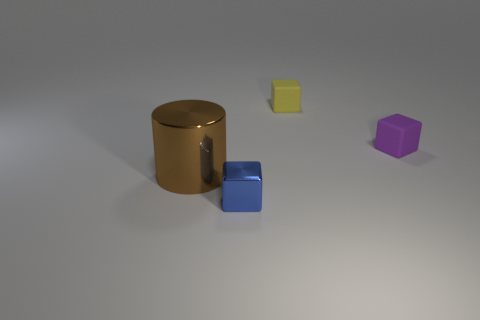Is there any other thing that is the same size as the metal cylinder?
Your response must be concise. No. There is a blue object that is the same shape as the purple matte object; what is its material?
Keep it short and to the point. Metal. How many things are tiny objects to the right of the blue shiny object or cubes to the right of the blue shiny block?
Your answer should be very brief. 2. The small yellow thing that is made of the same material as the purple block is what shape?
Ensure brevity in your answer.  Cube. How many small yellow matte blocks are there?
Make the answer very short. 1. What number of things are either things that are behind the tiny blue object or purple things?
Offer a terse response. 3. What number of other things are the same color as the big object?
Provide a short and direct response. 0. What number of tiny things are rubber cubes or purple rubber objects?
Make the answer very short. 2. Are there more tiny metallic objects than things?
Ensure brevity in your answer.  No. Do the blue object and the large cylinder have the same material?
Give a very brief answer. Yes. 